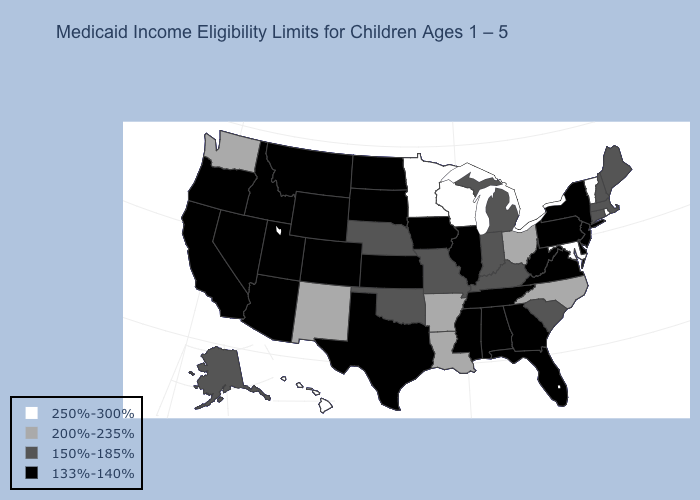What is the value of Pennsylvania?
Answer briefly. 133%-140%. Which states have the lowest value in the USA?
Keep it brief. Alabama, Arizona, California, Colorado, Delaware, Florida, Georgia, Idaho, Illinois, Iowa, Kansas, Mississippi, Montana, Nevada, New Jersey, New York, North Dakota, Oregon, Pennsylvania, South Dakota, Tennessee, Texas, Utah, Virginia, West Virginia, Wyoming. Name the states that have a value in the range 250%-300%?
Give a very brief answer. Hawaii, Maryland, Minnesota, Rhode Island, Vermont, Wisconsin. Among the states that border Connecticut , does Massachusetts have the lowest value?
Write a very short answer. No. Does the first symbol in the legend represent the smallest category?
Quick response, please. No. What is the value of Kentucky?
Keep it brief. 150%-185%. Name the states that have a value in the range 133%-140%?
Answer briefly. Alabama, Arizona, California, Colorado, Delaware, Florida, Georgia, Idaho, Illinois, Iowa, Kansas, Mississippi, Montana, Nevada, New Jersey, New York, North Dakota, Oregon, Pennsylvania, South Dakota, Tennessee, Texas, Utah, Virginia, West Virginia, Wyoming. What is the value of Iowa?
Keep it brief. 133%-140%. Does Arizona have the lowest value in the West?
Quick response, please. Yes. Name the states that have a value in the range 250%-300%?
Write a very short answer. Hawaii, Maryland, Minnesota, Rhode Island, Vermont, Wisconsin. Which states have the highest value in the USA?
Be succinct. Hawaii, Maryland, Minnesota, Rhode Island, Vermont, Wisconsin. How many symbols are there in the legend?
Write a very short answer. 4. Name the states that have a value in the range 150%-185%?
Write a very short answer. Alaska, Connecticut, Indiana, Kentucky, Maine, Massachusetts, Michigan, Missouri, Nebraska, New Hampshire, Oklahoma, South Carolina. Does Missouri have a higher value than Illinois?
Answer briefly. Yes. Name the states that have a value in the range 250%-300%?
Answer briefly. Hawaii, Maryland, Minnesota, Rhode Island, Vermont, Wisconsin. 